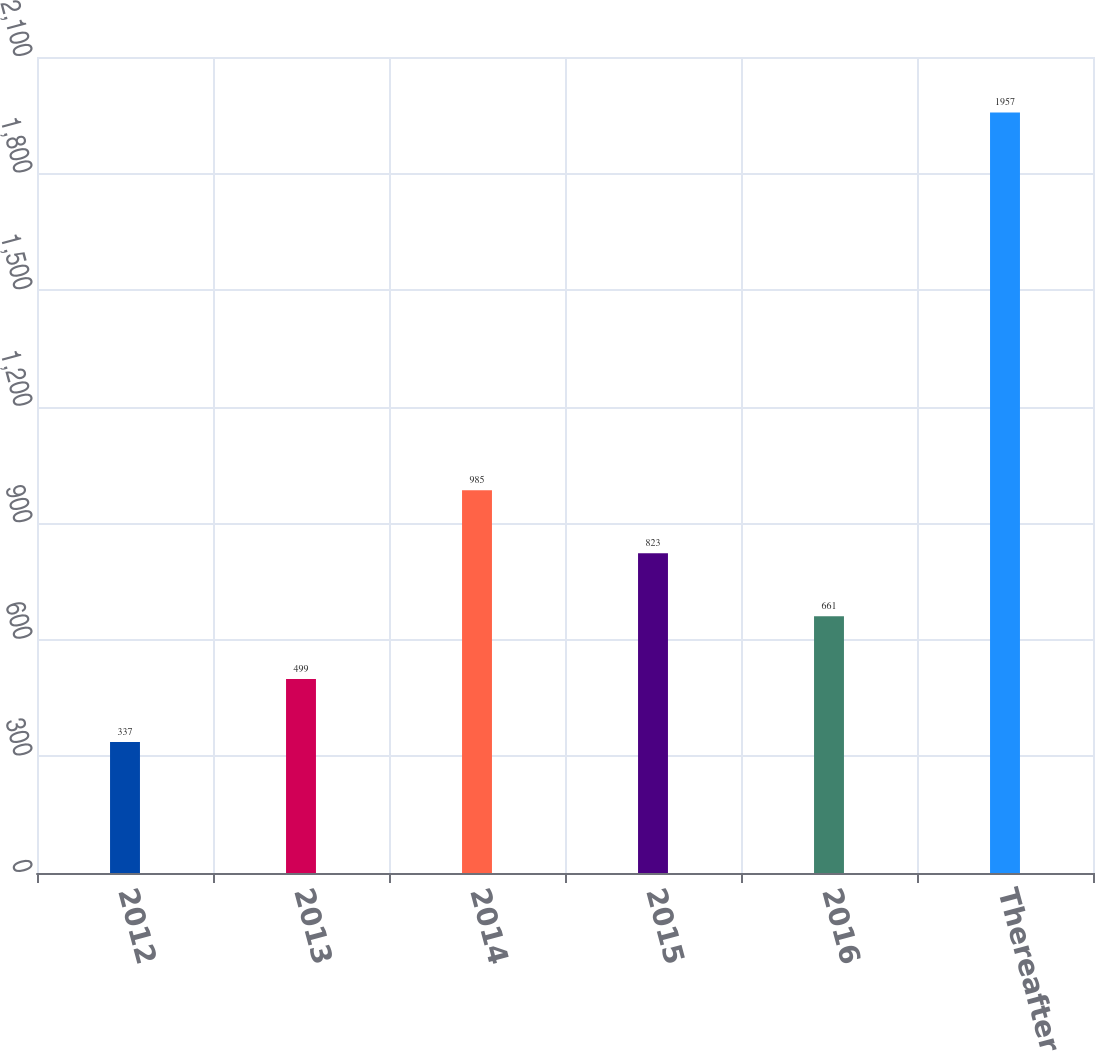<chart> <loc_0><loc_0><loc_500><loc_500><bar_chart><fcel>2012<fcel>2013<fcel>2014<fcel>2015<fcel>2016<fcel>Thereafter<nl><fcel>337<fcel>499<fcel>985<fcel>823<fcel>661<fcel>1957<nl></chart> 